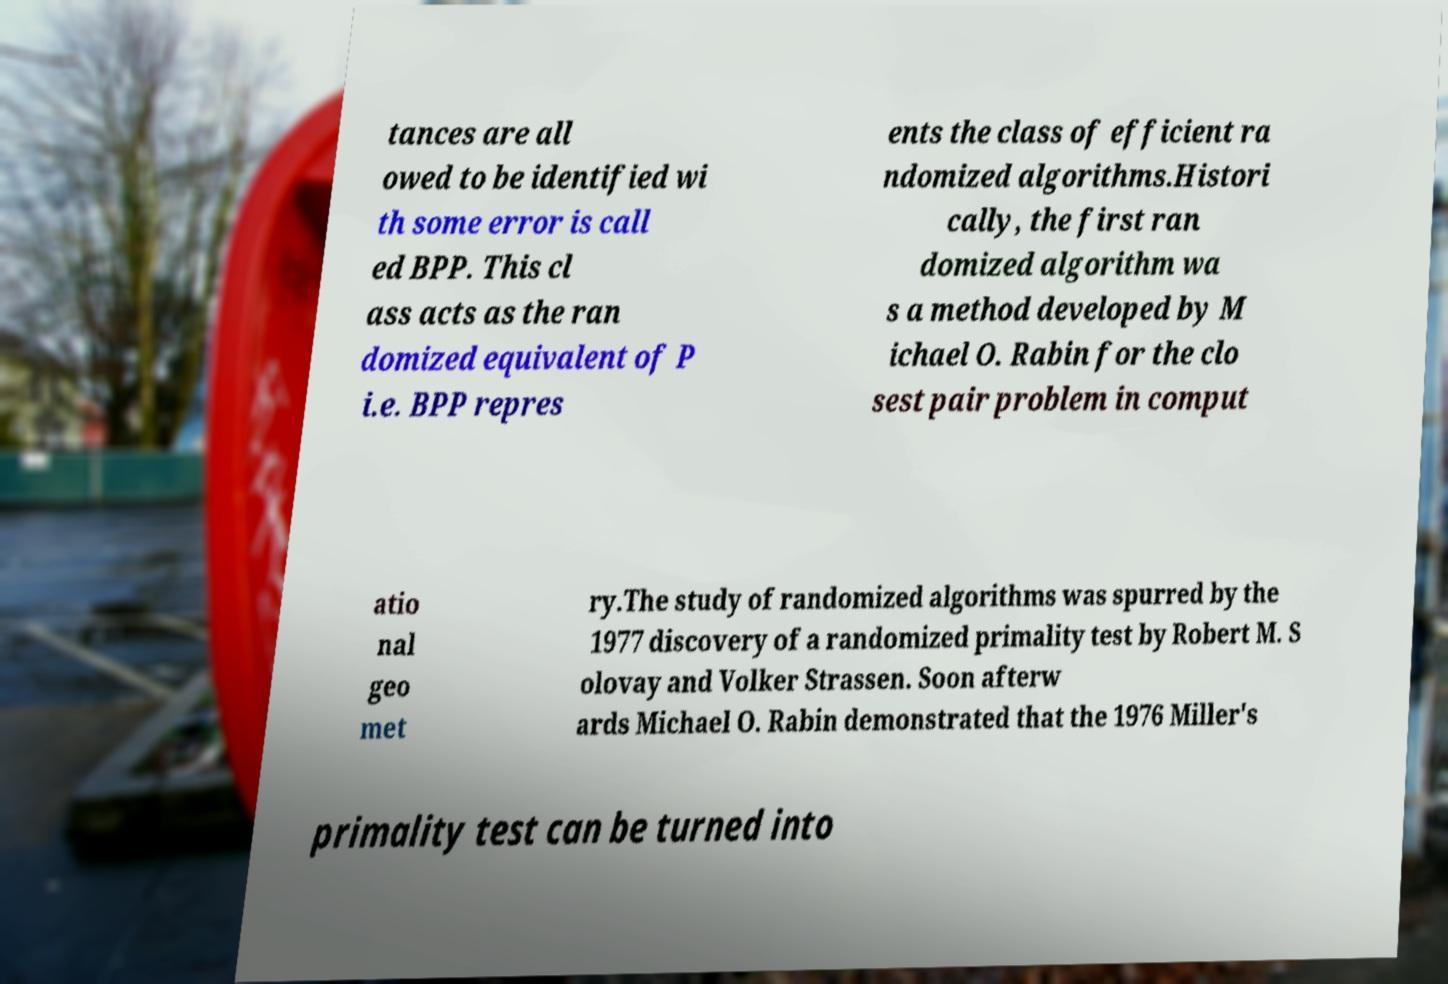For documentation purposes, I need the text within this image transcribed. Could you provide that? tances are all owed to be identified wi th some error is call ed BPP. This cl ass acts as the ran domized equivalent of P i.e. BPP repres ents the class of efficient ra ndomized algorithms.Histori cally, the first ran domized algorithm wa s a method developed by M ichael O. Rabin for the clo sest pair problem in comput atio nal geo met ry.The study of randomized algorithms was spurred by the 1977 discovery of a randomized primality test by Robert M. S olovay and Volker Strassen. Soon afterw ards Michael O. Rabin demonstrated that the 1976 Miller's primality test can be turned into 